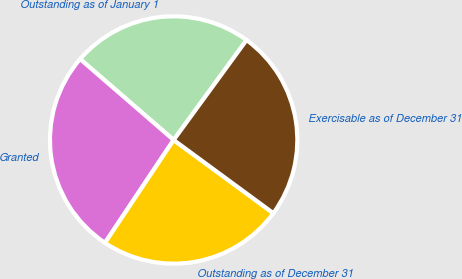Convert chart. <chart><loc_0><loc_0><loc_500><loc_500><pie_chart><fcel>Outstanding as of January 1<fcel>Granted<fcel>Outstanding as of December 31<fcel>Exercisable as of December 31<nl><fcel>23.68%<fcel>26.98%<fcel>24.29%<fcel>25.05%<nl></chart> 